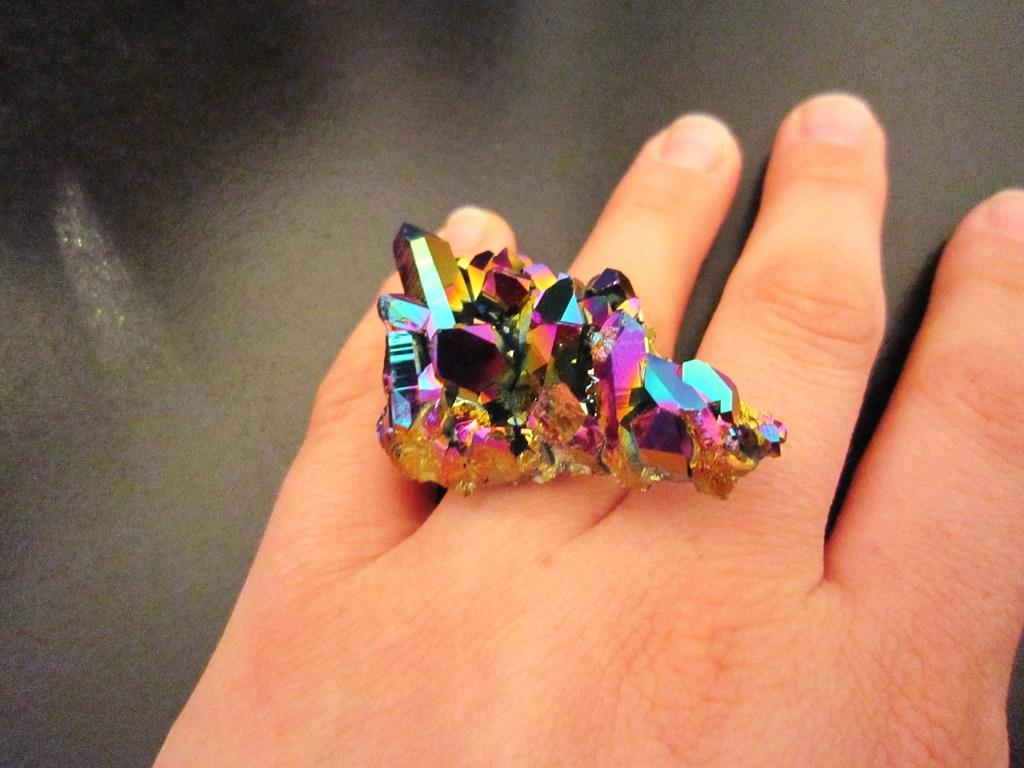What is the main subject of the image? There is an object in the image. Where is the object located? The object is on a person's hand. What type of pickle is being used to cause destruction in the image? There is no pickle or destruction present in the image. What type of rake is being used to gather leaves in the image? There is no rake or leaves present in the image. 